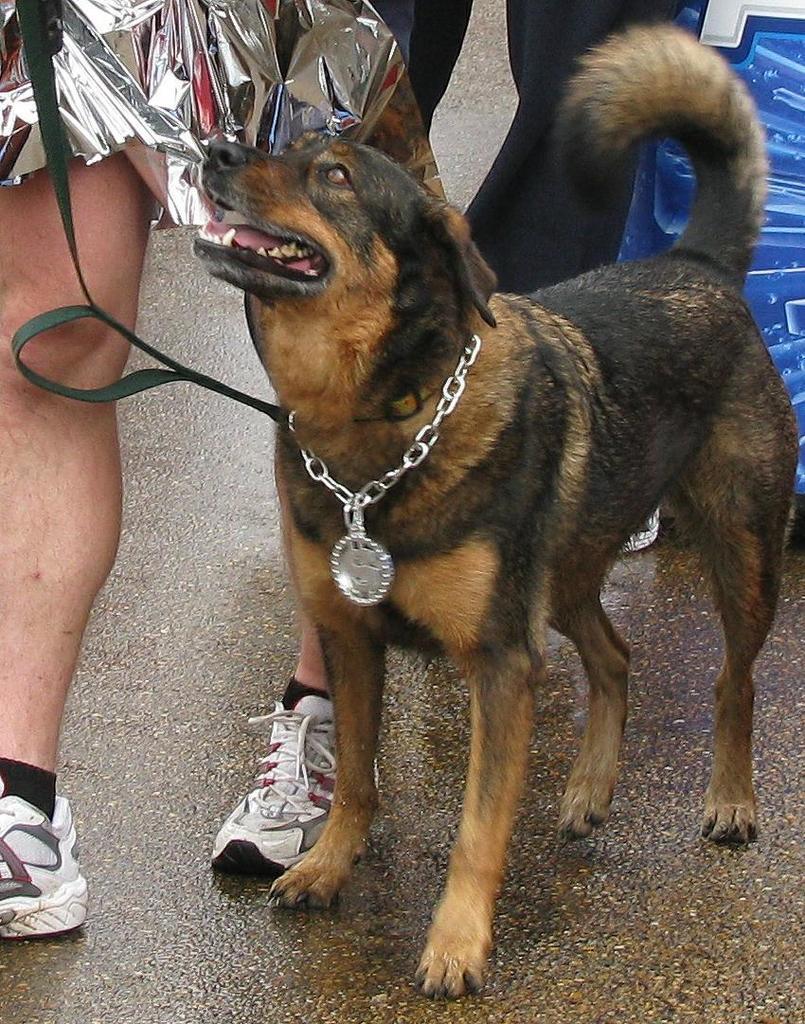How would you summarize this image in a sentence or two? In this image there are some people and also there is one dog, in the background there is one board and at the bottom there is a walkway and one person is holding some belt. 